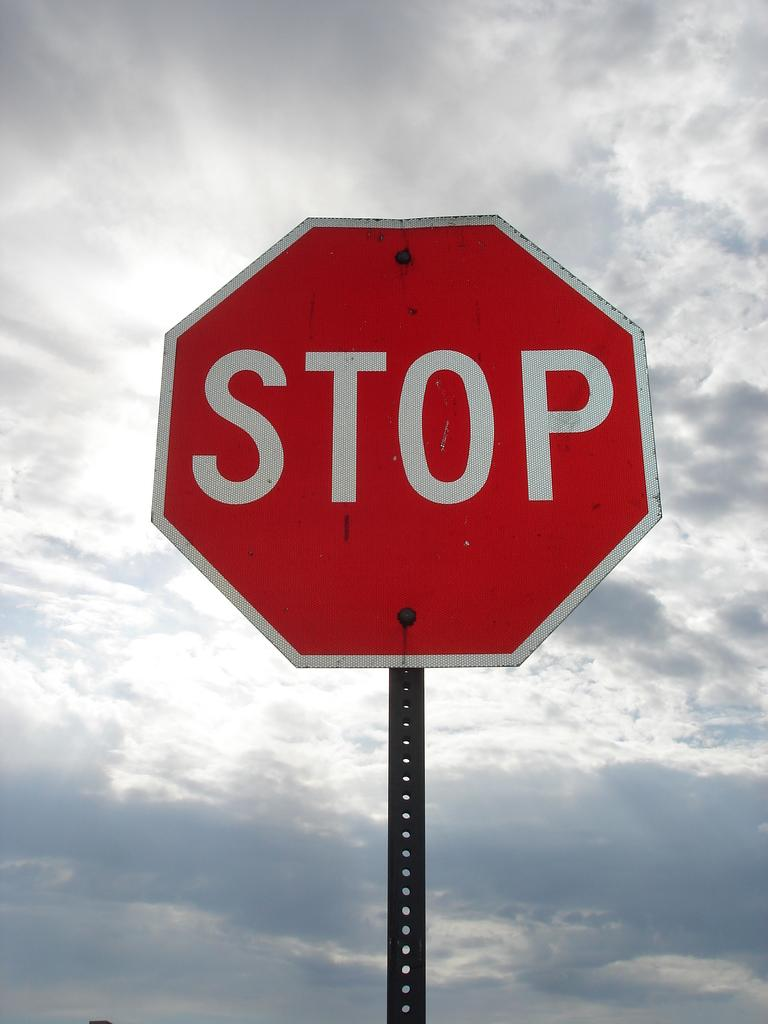<image>
Create a compact narrative representing the image presented. a stop sign that is located outside in the daytime 